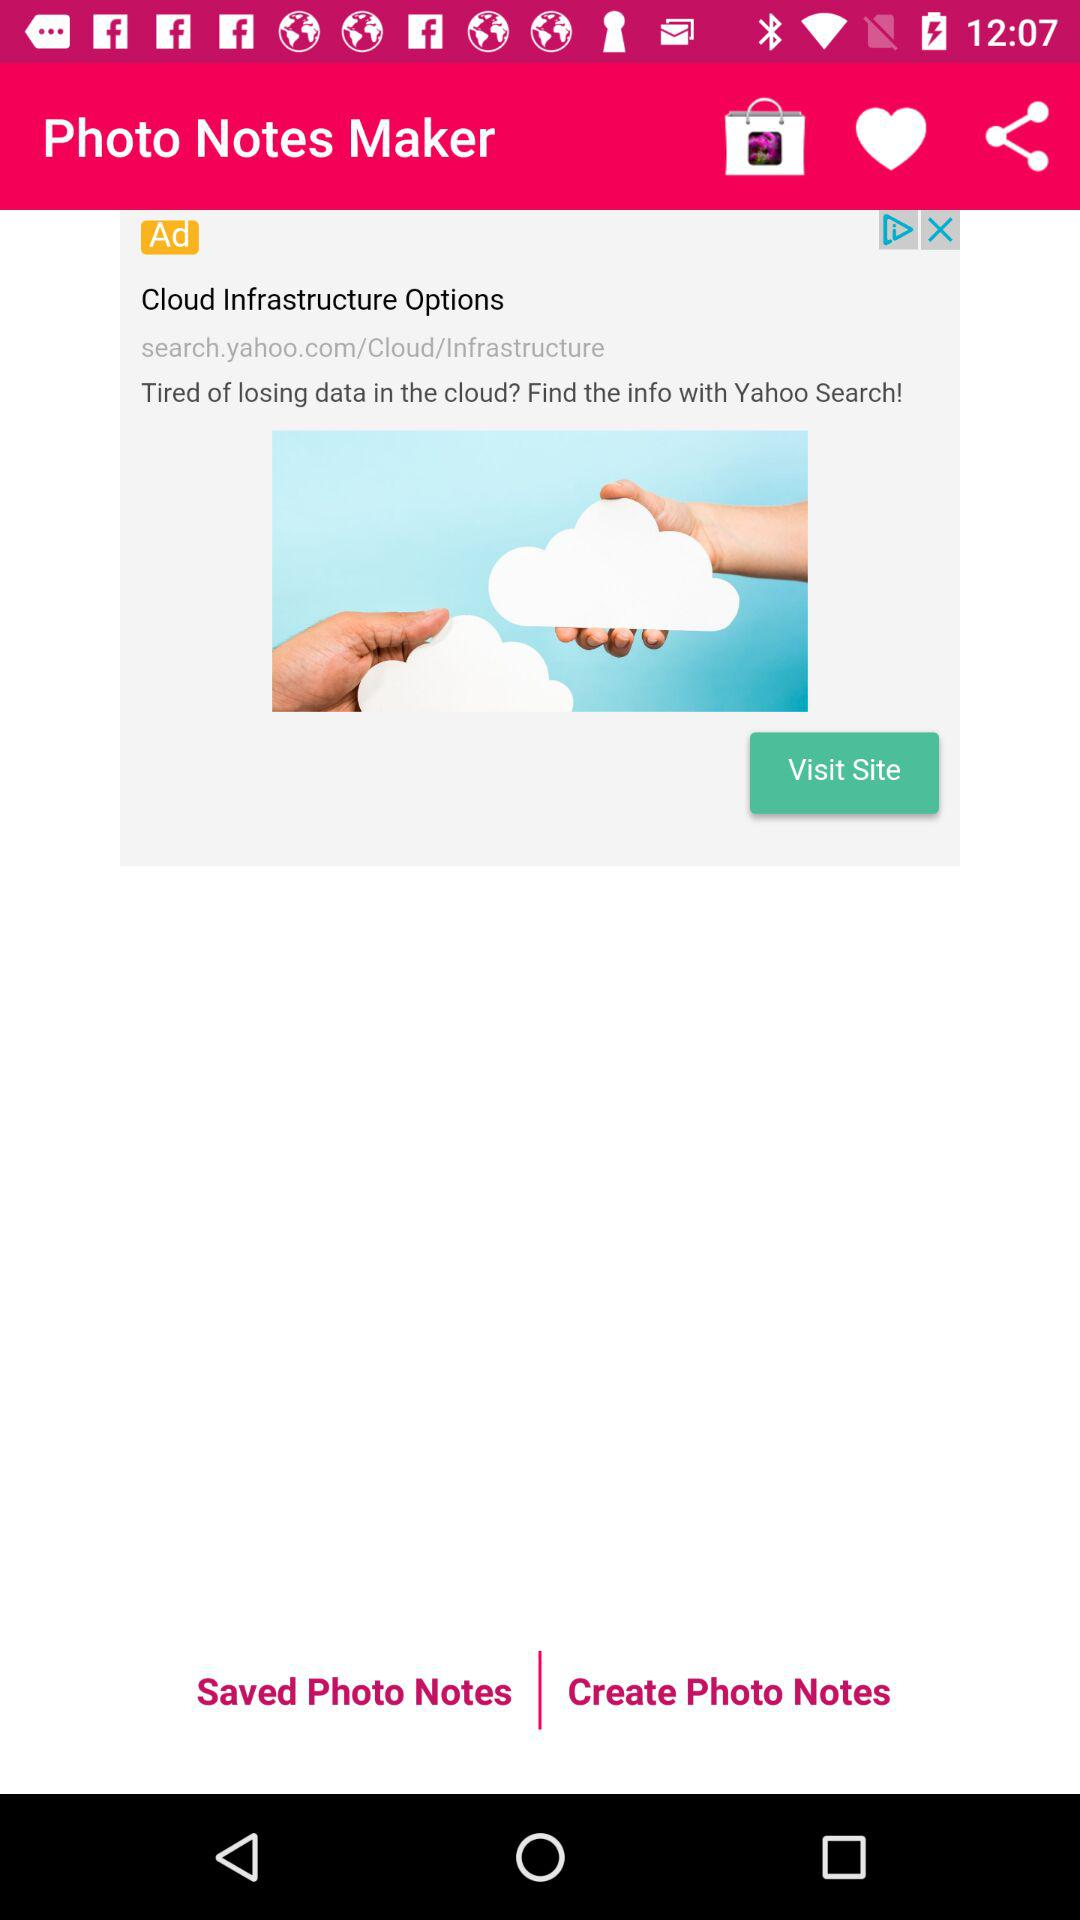What is the application name? The application name is "Photo Notes Maker". 